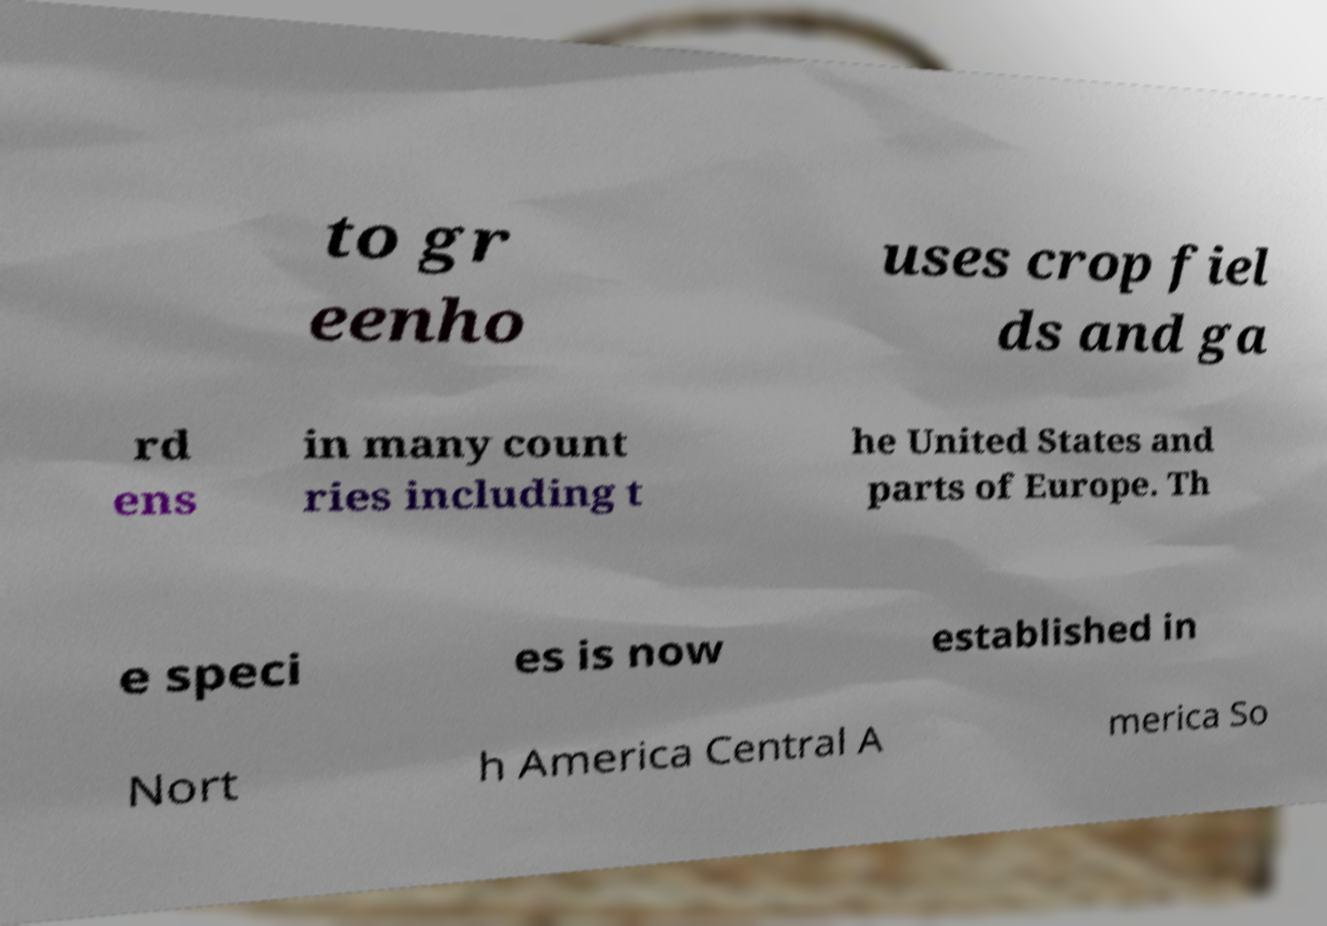Could you assist in decoding the text presented in this image and type it out clearly? to gr eenho uses crop fiel ds and ga rd ens in many count ries including t he United States and parts of Europe. Th e speci es is now established in Nort h America Central A merica So 